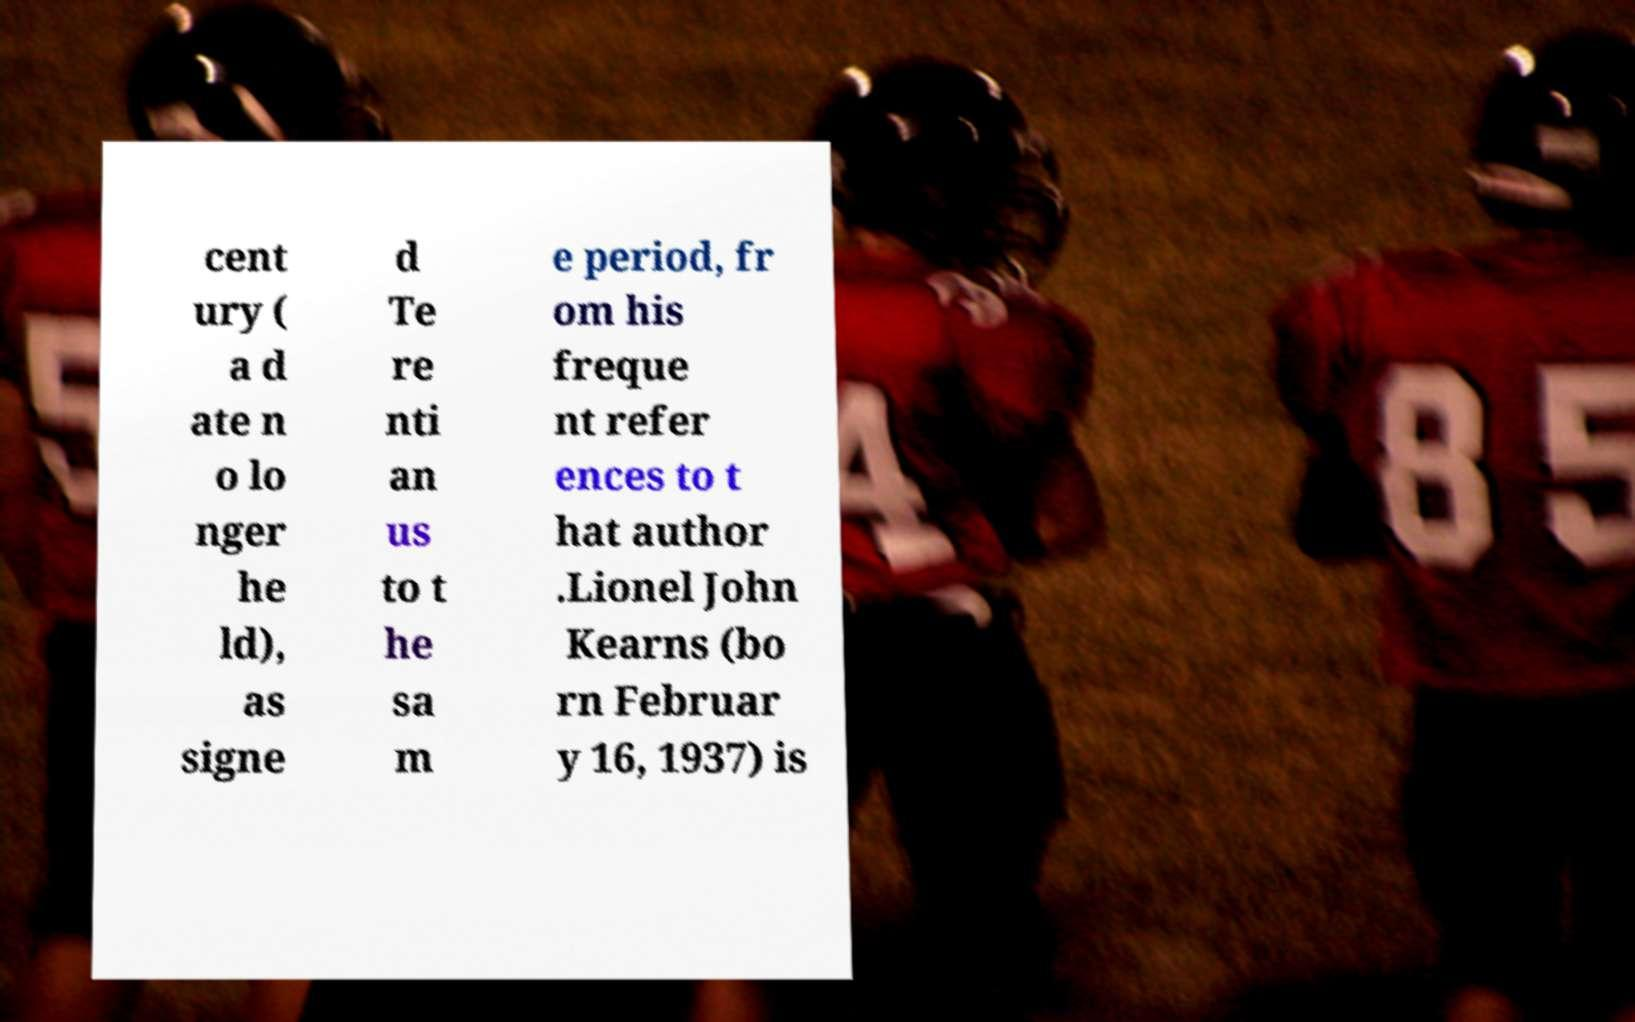I need the written content from this picture converted into text. Can you do that? cent ury ( a d ate n o lo nger he ld), as signe d Te re nti an us to t he sa m e period, fr om his freque nt refer ences to t hat author .Lionel John Kearns (bo rn Februar y 16, 1937) is 